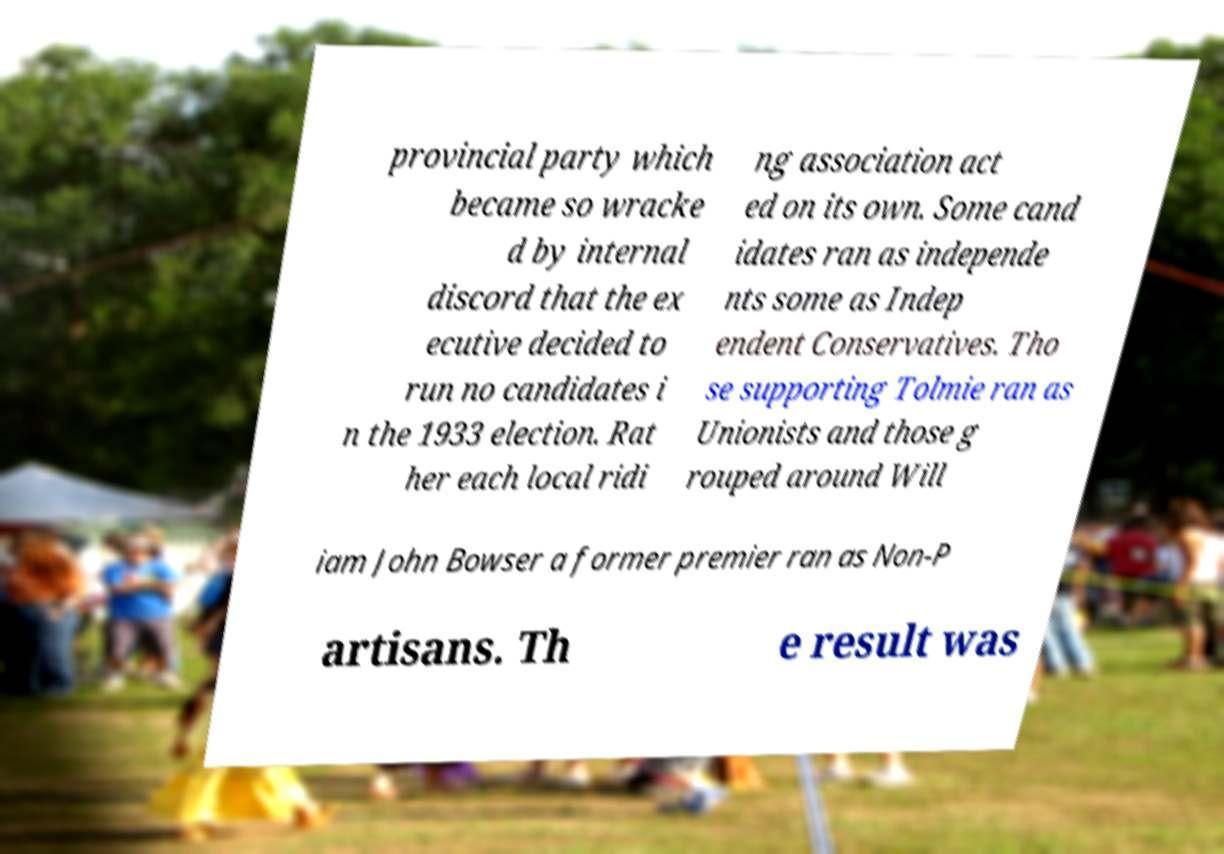Could you extract and type out the text from this image? provincial party which became so wracke d by internal discord that the ex ecutive decided to run no candidates i n the 1933 election. Rat her each local ridi ng association act ed on its own. Some cand idates ran as independe nts some as Indep endent Conservatives. Tho se supporting Tolmie ran as Unionists and those g rouped around Will iam John Bowser a former premier ran as Non-P artisans. Th e result was 